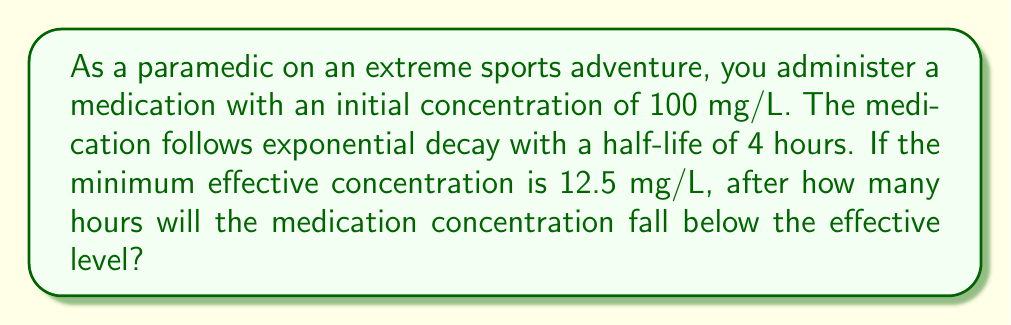Show me your answer to this math problem. Let's approach this step-by-step using exponential decay and logarithms:

1) The exponential decay formula is:

   $$C(t) = C_0 \cdot e^{-kt}$$

   Where $C(t)$ is the concentration at time $t$, $C_0$ is the initial concentration, $k$ is the decay constant, and $t$ is time.

2) We need to find $k$ using the half-life. At half-life ($t_{1/2} = 4$ hours), the concentration is half the initial:

   $$\frac{1}{2}C_0 = C_0 \cdot e^{-k(4)}$$

3) Simplify and solve for $k$:

   $$\frac{1}{2} = e^{-4k}$$
   $$\ln(\frac{1}{2}) = -4k$$
   $$k = \frac{\ln(2)}{4} \approx 0.1733$$

4) Now we can use the full decay equation to find when $C(t) = 12.5$ mg/L:

   $$12.5 = 100 \cdot e^{-0.1733t}$$

5) Solve for $t$ using logarithms:

   $$\frac{12.5}{100} = e^{-0.1733t}$$
   $$\ln(0.125) = -0.1733t$$
   $$t = \frac{\ln(0.125)}{-0.1733} \approx 12$$

Therefore, the medication concentration will fall below the effective level after approximately 12 hours.
Answer: The medication concentration will fall below the effective level after approximately 12 hours. 